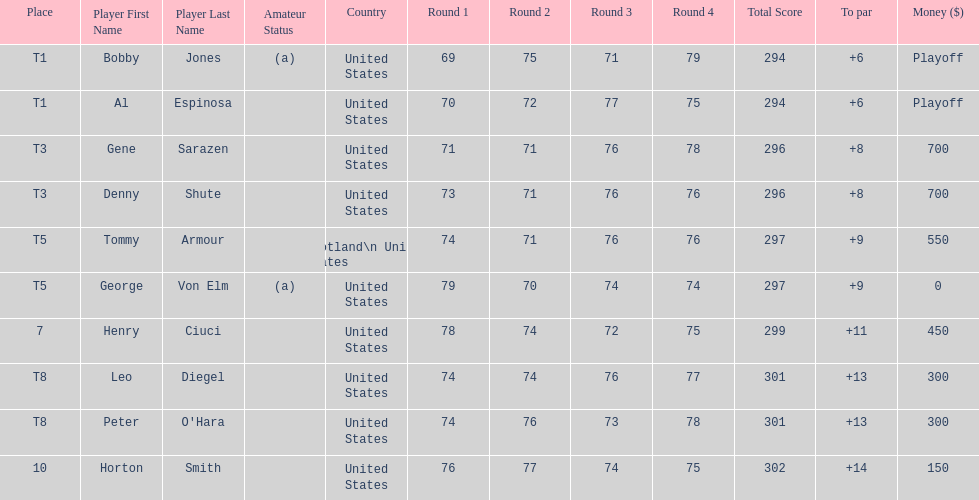Which two players tied for first place? Bobby Jones (a), Al Espinosa. 